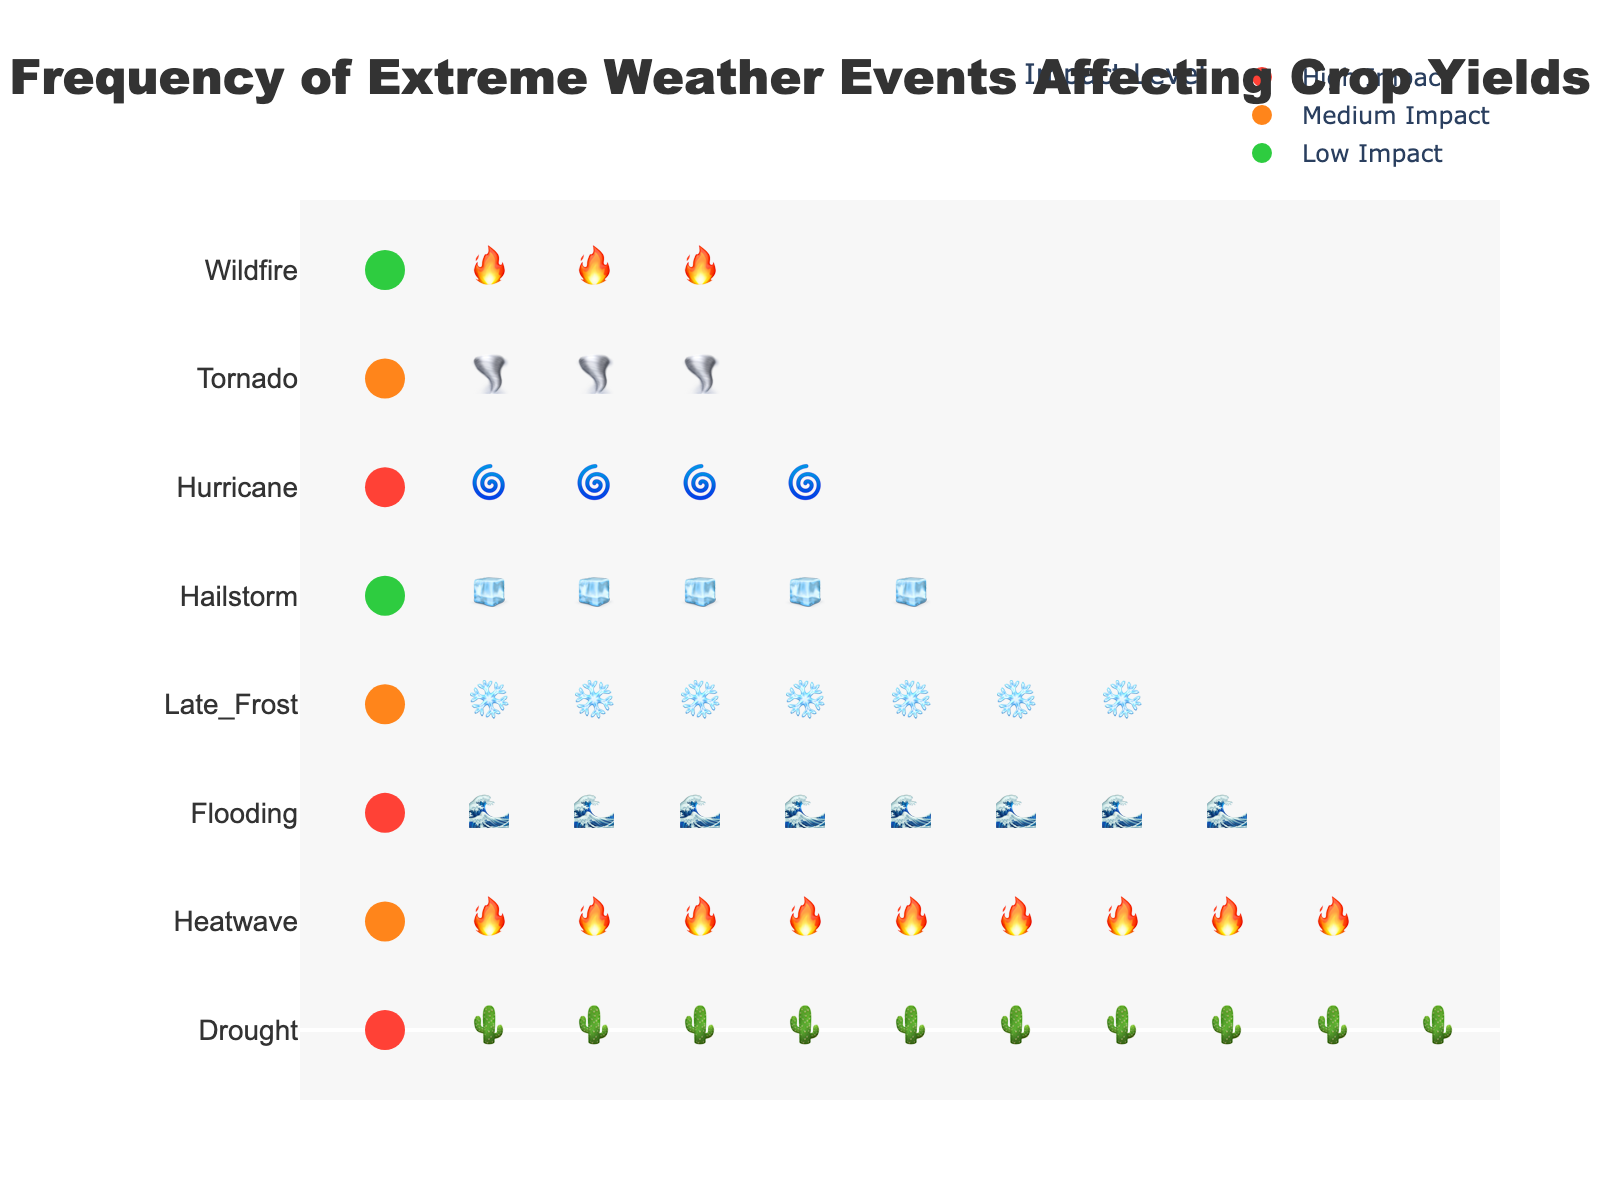What's the title of the figure? The title is written at the top of the figure in a large and bold font. It reads "Frequency of Extreme Weather Events Affecting Crop Yields."
Answer: Frequency of Extreme Weather Events Affecting Crop Yields How many weather events are depicted in the figure? Each row represents a weather event, and there are 8 rows in the figure.
Answer: 8 Which weather event has the highest frequency? The weather event with the most icons in its row is "Drought," which has 8 icons.
Answer: Drought Which two weather events have the lowest frequency? The rows with the fewest icons are "Tornado" and "Wildfire," each with 2 icons.
Answer: Tornado and Wildfire What color represents a "High" impact level? The color bar on the left side assigns colors to impact levels. The "High" impact level is represented by red.
Answer: Red Which weather event has a "Low" impact level but a frequency of more than 2? "Hailstorm" has a "Low" impact level and a frequency of 4, as indicated by the icons and the color coding.
Answer: Hailstorm What's the sum of the frequencies of events with a "Medium" impact level? The frequencies for "Medium" impact events are 7 (Heatwave), 5 (Late_Frost), and 2 (Tornado). Summing these gives 7+5+2 = 14.
Answer: 14 Between "Flooding" and "Hurricane," which has a higher frequency and by how much? "Flooding" has a frequency of 6, and "Hurricane" has a frequency of 3. The difference is 6 - 3 = 3.
Answer: Flooding by 3 Which weather event with a "High" impact level has the fewest occurrences? "Hurricane" has the fewest occurrences among the "High" impact level events, with a frequency of 3.
Answer: Hurricane In terms of frequency, which event is closest to "Flooding" but has a different impact level? "Late_Frost" has a frequency of 5 and an impact level of "Medium," which is close to "Flooding" (frequency 6, "High" impact).
Answer: Late_Frost 